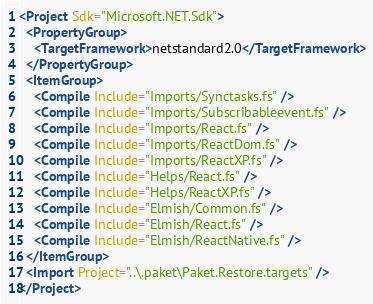<code> <loc_0><loc_0><loc_500><loc_500><_XML_><Project Sdk="Microsoft.NET.Sdk">
  <PropertyGroup>
    <TargetFramework>netstandard2.0</TargetFramework>
  </PropertyGroup>
  <ItemGroup>
    <Compile Include="Imports/Synctasks.fs" />
    <Compile Include="Imports/Subscribableevent.fs" />
    <Compile Include="Imports/React.fs" />
    <Compile Include="Imports/ReactDom.fs" />
    <Compile Include="Imports/ReactXP.fs" />
    <Compile Include="Helps/React.fs" />
    <Compile Include="Helps/ReactXP.fs" />
    <Compile Include="Elmish/Common.fs" />
    <Compile Include="Elmish/React.fs" />
    <Compile Include="Elmish/ReactNative.fs" />
  </ItemGroup>
  <Import Project="..\.paket\Paket.Restore.targets" />
</Project></code> 